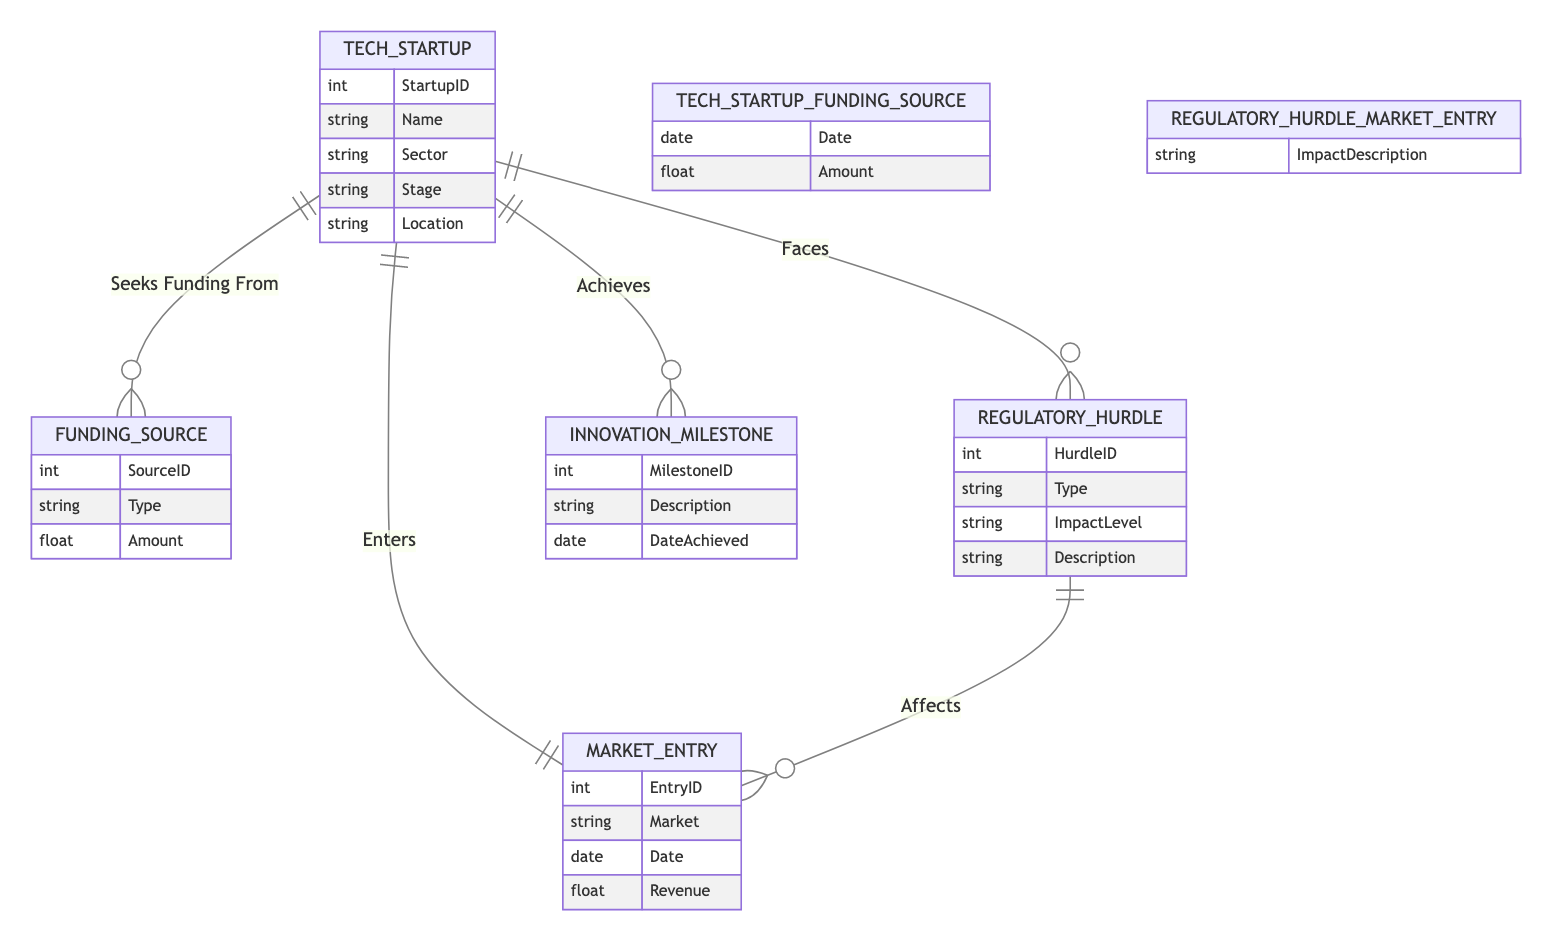What entities are present in the diagram? The diagram comprises five entities: Tech Startup, Funding Source, Regulatory Hurdle, Innovation Milestone, and Market Entry.
Answer: Tech Startup, Funding Source, Regulatory Hurdle, Innovation Milestone, Market Entry How many attributes does the Funding Source entity have? The Funding Source entity has three attributes: SourceID, Type, and Amount.
Answer: 3 What relationship does a Tech Startup have with an Innovation Milestone? A Tech Startup has the "Achieves" relationship with an Innovation Milestone, indicating that a startup can achieve multiple milestones.
Answer: Achieves How many regulatory hurdles can a Tech Startup face? A Tech Startup can face many regulatory hurdles, as indicated by the one-to-many relationship between Tech Startup and Regulatory Hurdle.
Answer: Many What is the type of relationship between Regulatory Hurdle and Market Entry? The relationship between Regulatory Hurdle and Market Entry is "Affects," indicating that regulatory hurdles can impact market entry.
Answer: Affects Which entity has a one-to-one relationship with Tech Startup? The Market Entry entity has a one-to-one relationship with the Tech Startup entity, meaning each startup enters exactly one market.
Answer: Market Entry What does the ImpactLevel attribute in Regulatory Hurdle signify? The ImpactLevel attribute signifies the severity or extent of impact a regulatory hurdle has on the startup's operations.
Answer: Severity What action does a Tech Startup take in relation to a Funding Source? A Tech Startup seeks funding from funding sources, which means startups look for financial support through various funding channels.
Answer: Seeks Funding From What describes the relationship attributes of the "Seeks Funding From" relationship? The relationship attribute describes the Date and Amount of funding sought by the Tech Startup from the Funding Source.
Answer: Date, Amount How does a regulatory hurdle impact market entry for startups? A regulatory hurdle can have a varying impact described in the Relationship attribute "ImpactDescription," expressing specific effects on market entry.
Answer: ImpactDescription 